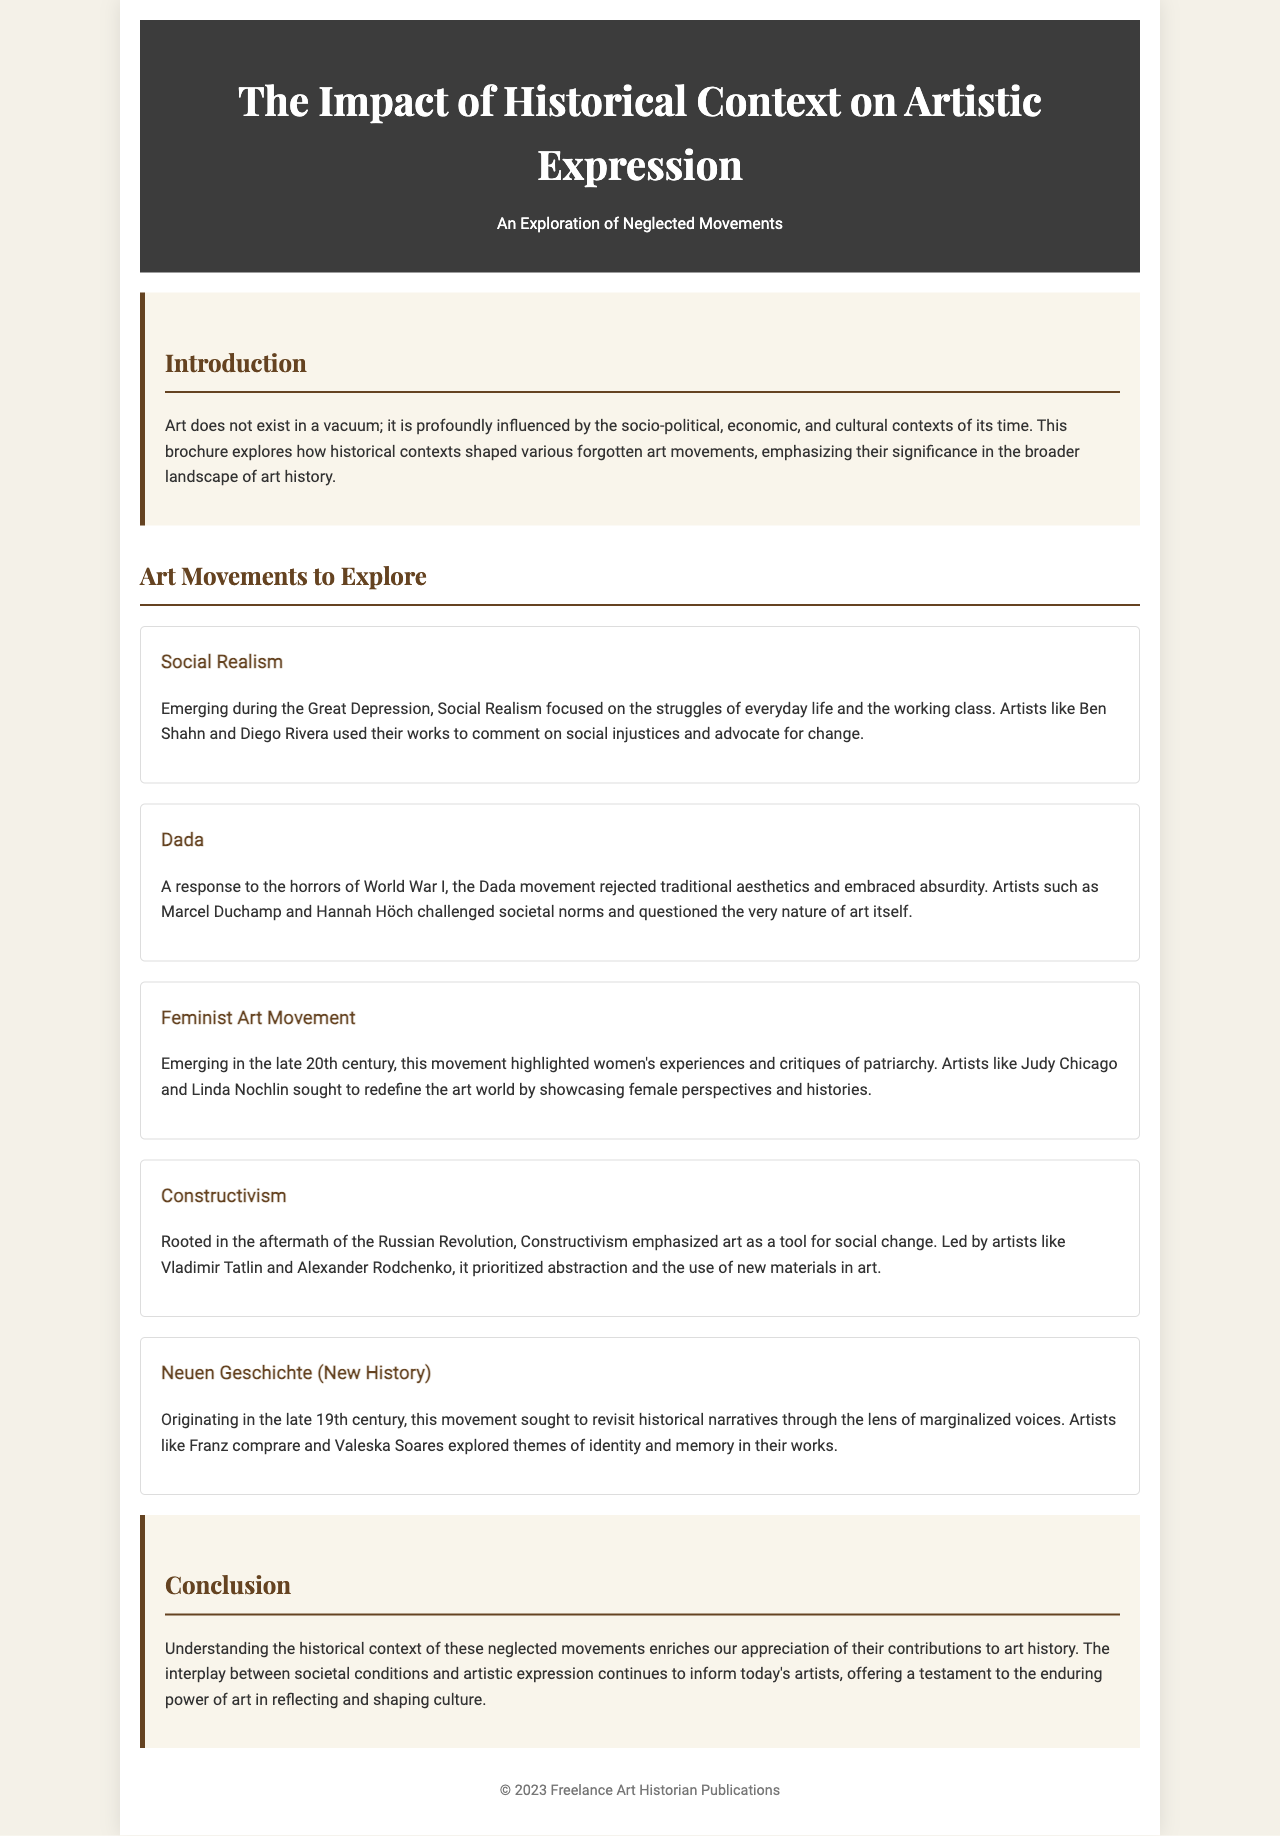What is the title of the brochure? The title of the brochure is presented clearly at the top, stating its focus on the impact of historical context on artistic expression.
Answer: The Impact of Historical Context on Artistic Expression Who is the author of the brochure? The author's name is indicated in the footer as part of the publication's information.
Answer: Freelance Art Historian Publications What art movement focused on the struggles of everyday life? This is mentioned in the description of the movement that emerged during the Great Depression.
Answer: Social Realism Which artist is associated with the Dada movement? The document lists several artists, with one specifically linked to the Dada movement.
Answer: Marcel Duchamp What was the primary aim of Constructivism? The goal of Constructivism is articulated in its description, emphasizing its role in social change.
Answer: Social change In what century did the Feminist Art Movement emerge? The text notes the emergence of this movement, providing a specific time frame related to its historical context.
Answer: Late 20th century What two themes are explored in the Neuen Geschichte movement? The brochure mentions specific themes revisited by this movement through marginalized voices.
Answer: Identity and memory How many art movements are discussed in the brochure? The document enumerates various movements, providing a clear count within its sections.
Answer: Five What is a lasting impact of understanding these neglected movements? The conclusion summarizes the significance of historical context on current artistic expression.
Answer: Enduring power of art 